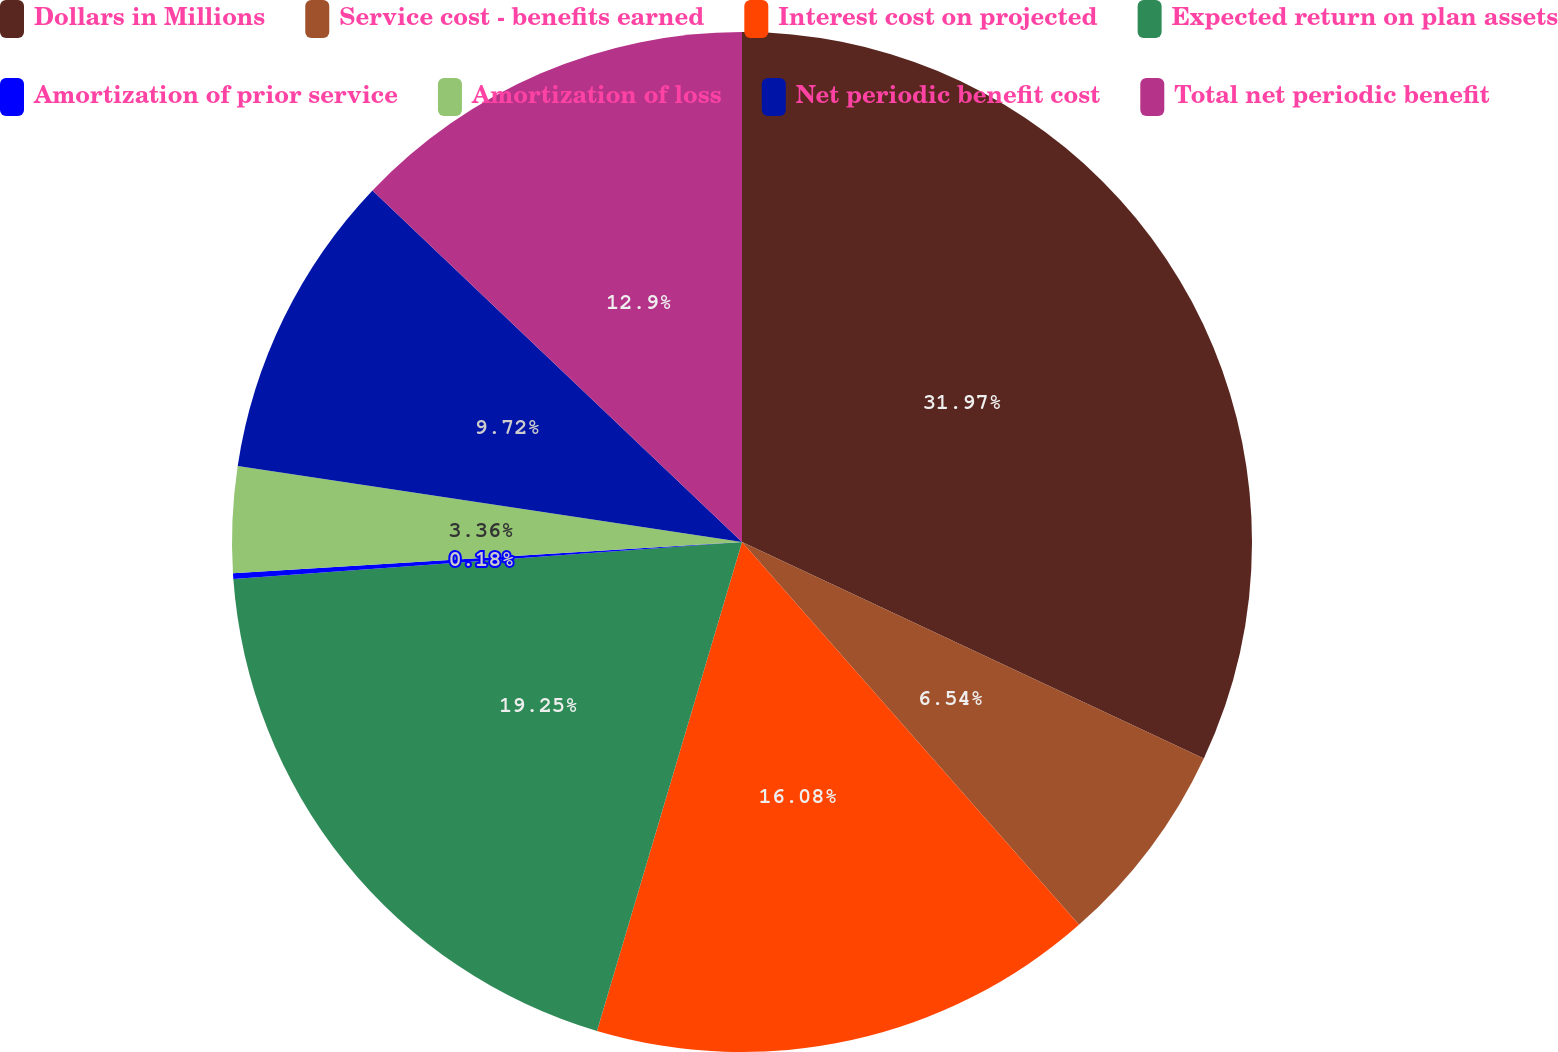<chart> <loc_0><loc_0><loc_500><loc_500><pie_chart><fcel>Dollars in Millions<fcel>Service cost - benefits earned<fcel>Interest cost on projected<fcel>Expected return on plan assets<fcel>Amortization of prior service<fcel>Amortization of loss<fcel>Net periodic benefit cost<fcel>Total net periodic benefit<nl><fcel>31.98%<fcel>6.54%<fcel>16.08%<fcel>19.26%<fcel>0.18%<fcel>3.36%<fcel>9.72%<fcel>12.9%<nl></chart> 